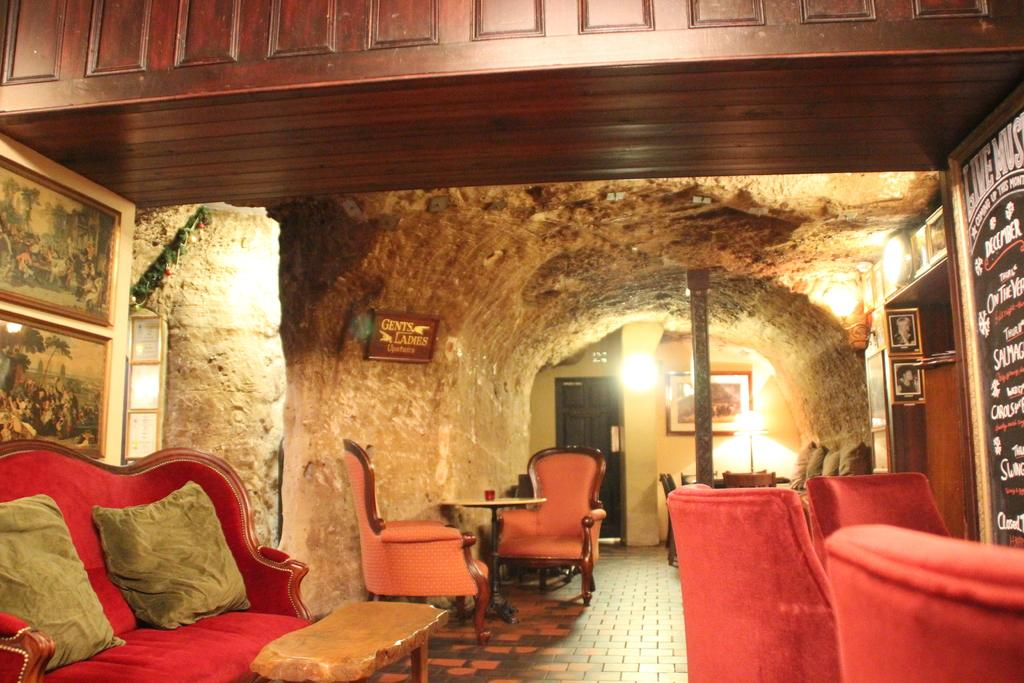What type of furniture can be seen in the image? There are chairs in the image. What can be used for illumination in the image? There is a light in the image. What is the tall, vertical object in the image? There is a pole in the image. What else is present on the floor in the image besides the chairs? There are other objects on the floor in the image. What is the boundary of the space depicted in the image? The image does not show a boundary or the entire space, so it cannot be determined from the image. How does the beginner navigate the pole in the image? There is no indication of a beginner or any activity involving the pole in the image. 